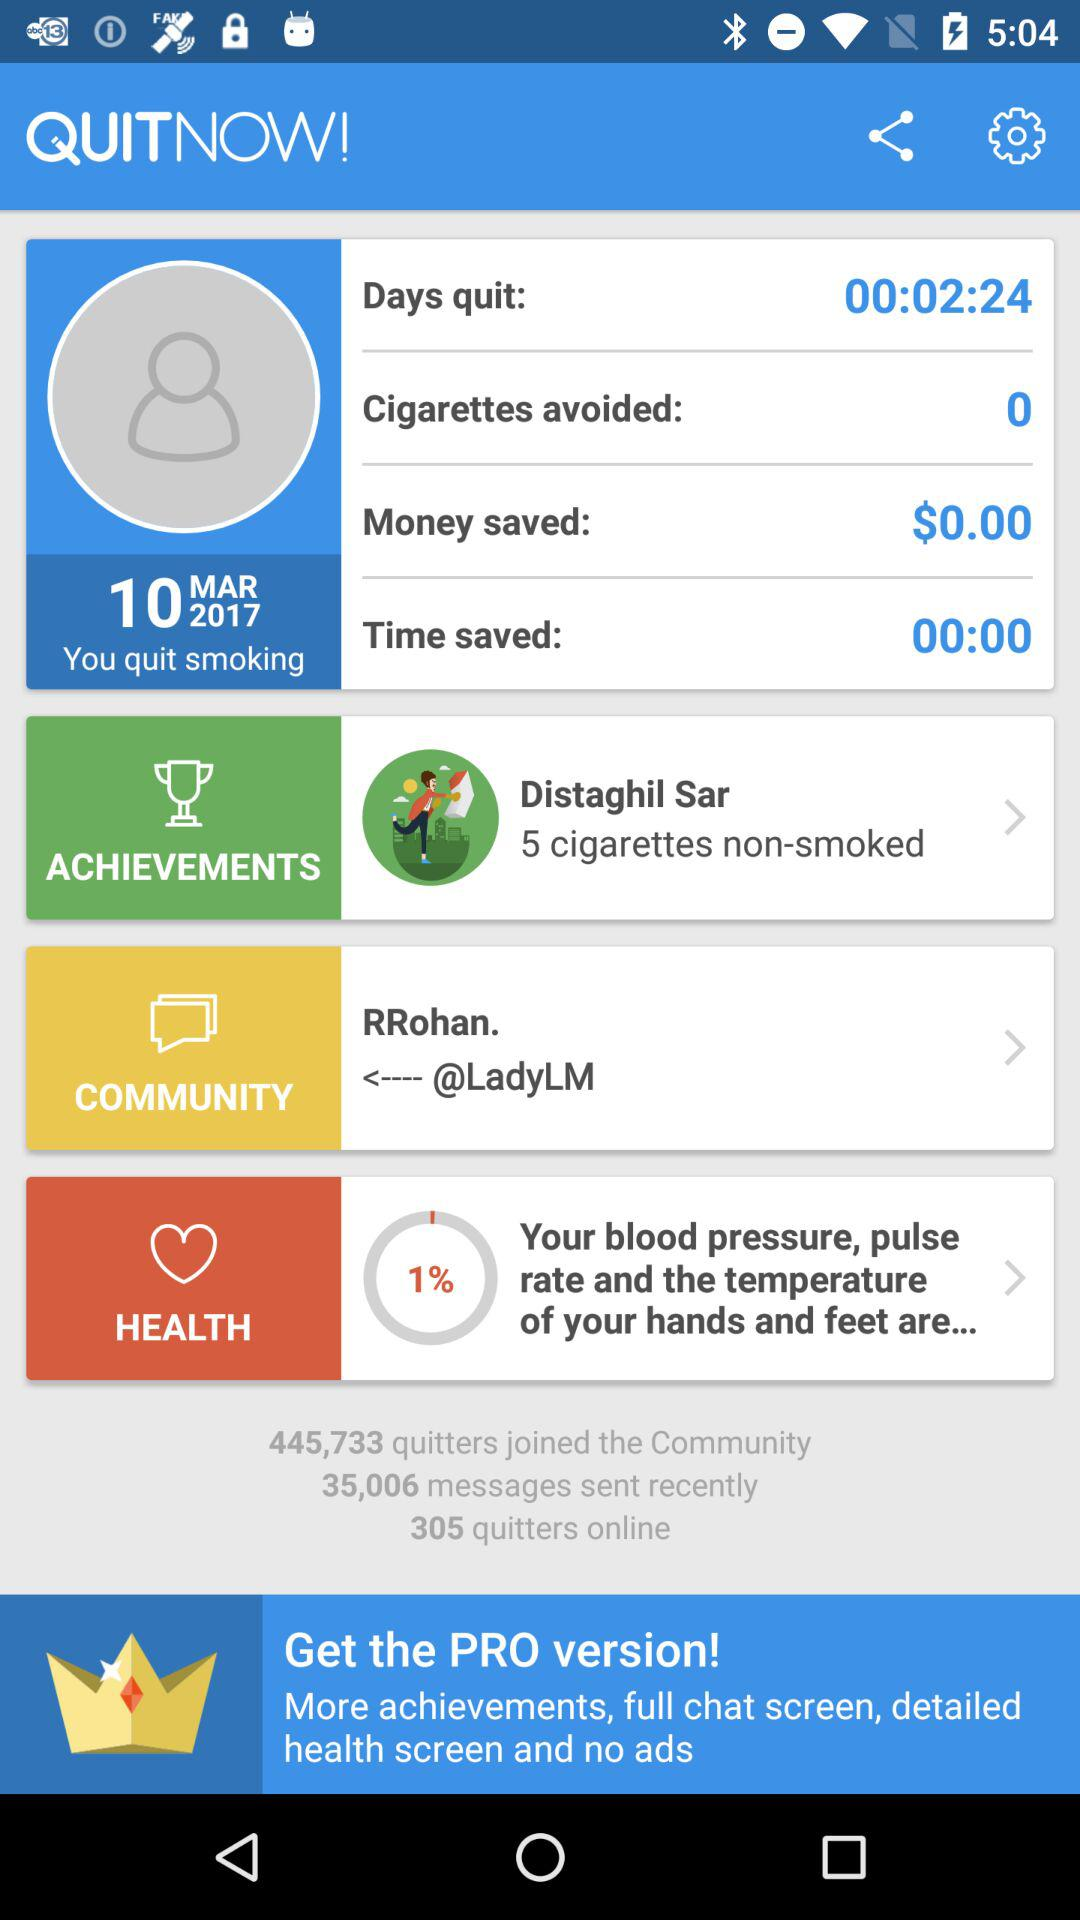What's the duration mentioned for "Days quit"? The mentioned duration is 2 minutes and 24 seconds. 